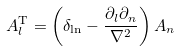Convert formula to latex. <formula><loc_0><loc_0><loc_500><loc_500>A _ { l } ^ { \text {T} } = \left ( \delta _ { \ln } - \frac { \partial _ { l } \partial _ { n } } { \nabla ^ { 2 } } \right ) A _ { n }</formula> 